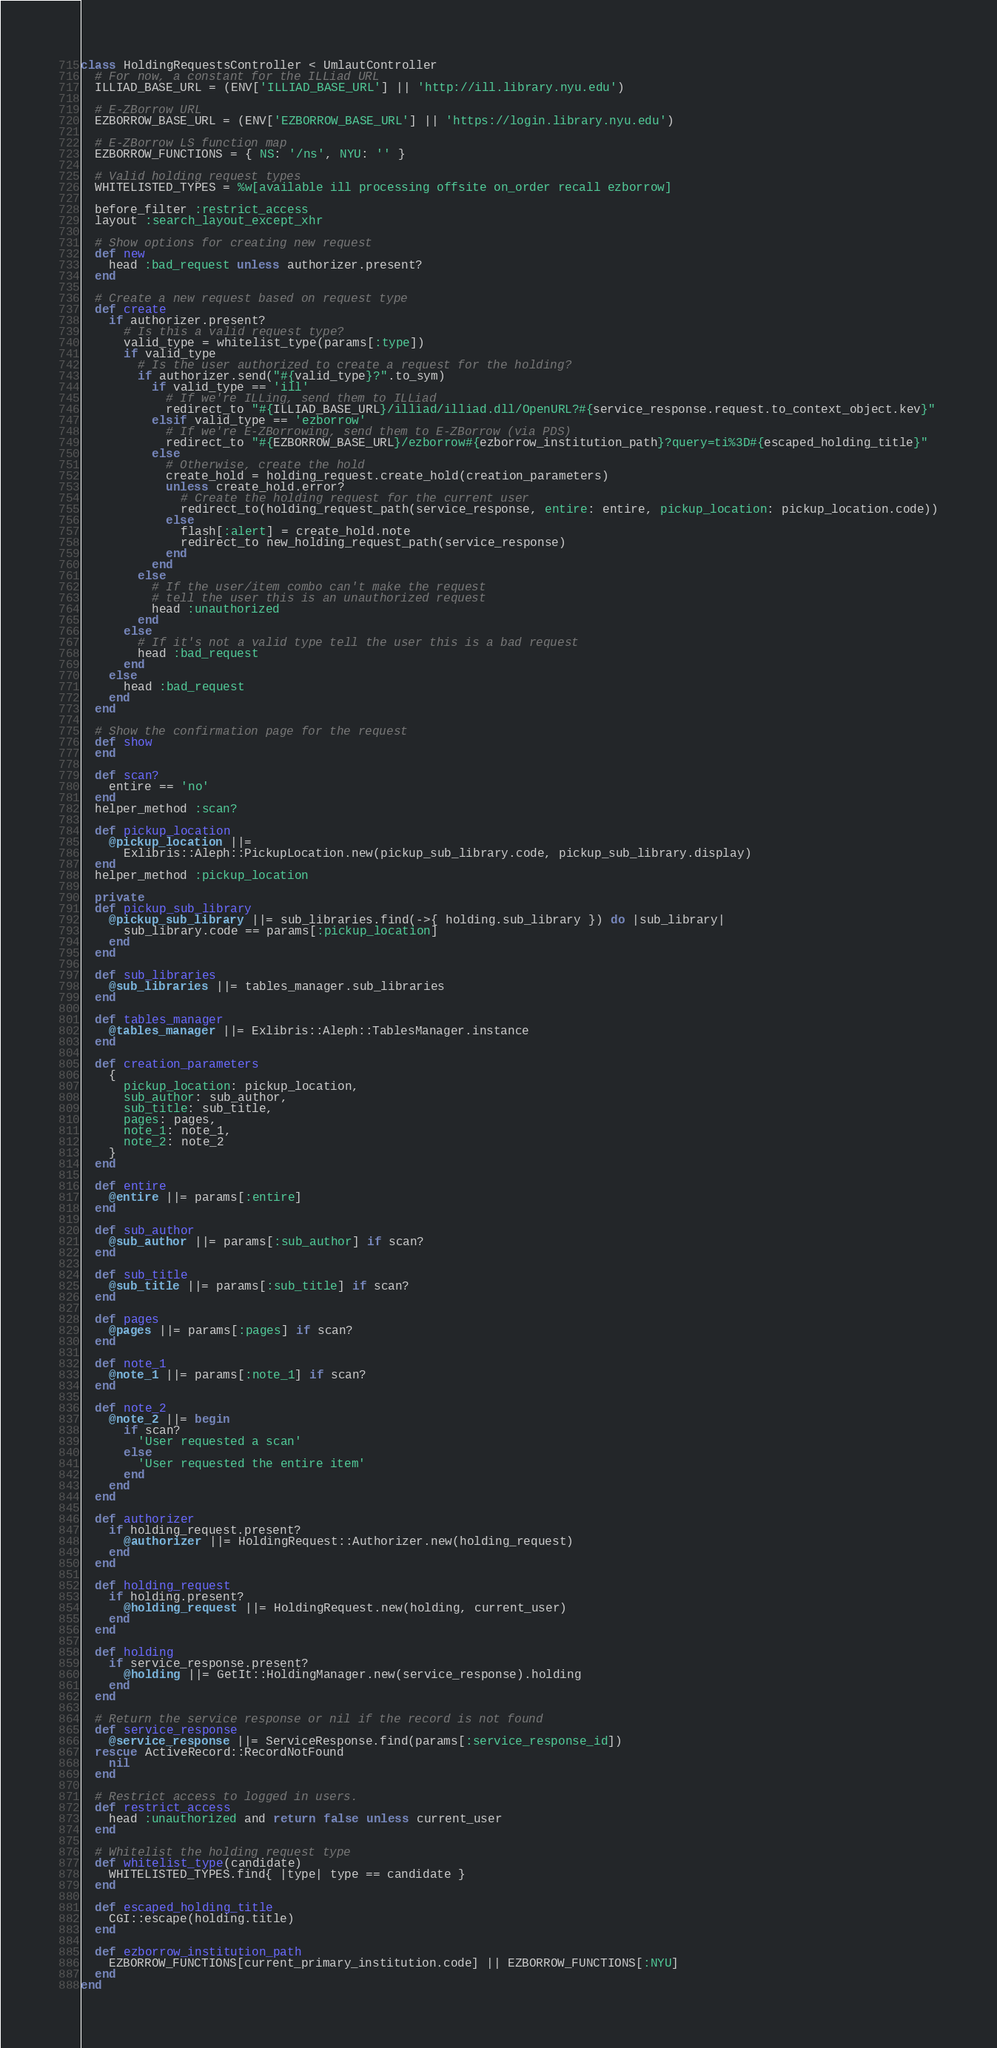<code> <loc_0><loc_0><loc_500><loc_500><_Ruby_>class HoldingRequestsController < UmlautController
  # For now, a constant for the ILLiad URL
  ILLIAD_BASE_URL = (ENV['ILLIAD_BASE_URL'] || 'http://ill.library.nyu.edu')

  # E-ZBorrow URL
  EZBORROW_BASE_URL = (ENV['EZBORROW_BASE_URL'] || 'https://login.library.nyu.edu')

  # E-ZBorrow LS function map
  EZBORROW_FUNCTIONS = { NS: '/ns', NYU: '' }

  # Valid holding request types
  WHITELISTED_TYPES = %w[available ill processing offsite on_order recall ezborrow]

  before_filter :restrict_access
  layout :search_layout_except_xhr

  # Show options for creating new request
  def new
    head :bad_request unless authorizer.present?
  end

  # Create a new request based on request type
  def create
    if authorizer.present?
      # Is this a valid request type?
      valid_type = whitelist_type(params[:type])
      if valid_type
        # Is the user authorized to create a request for the holding?
        if authorizer.send("#{valid_type}?".to_sym)
          if valid_type == 'ill'
            # If we're ILLing, send them to ILLiad
            redirect_to "#{ILLIAD_BASE_URL}/illiad/illiad.dll/OpenURL?#{service_response.request.to_context_object.kev}"
          elsif valid_type == 'ezborrow'
            # If we're E-ZBorrowing, send them to E-ZBorrow (via PDS)
            redirect_to "#{EZBORROW_BASE_URL}/ezborrow#{ezborrow_institution_path}?query=ti%3D#{escaped_holding_title}"
          else
            # Otherwise, create the hold
            create_hold = holding_request.create_hold(creation_parameters)
            unless create_hold.error?
              # Create the holding request for the current user
              redirect_to(holding_request_path(service_response, entire: entire, pickup_location: pickup_location.code))
            else
              flash[:alert] = create_hold.note
              redirect_to new_holding_request_path(service_response)
            end
          end
        else
          # If the user/item combo can't make the request
          # tell the user this is an unauthorized request
          head :unauthorized
        end
      else
        # If it's not a valid type tell the user this is a bad request
        head :bad_request
      end
    else
      head :bad_request
    end
  end

  # Show the confirmation page for the request
  def show
  end

  def scan?
    entire == 'no'
  end
  helper_method :scan?

  def pickup_location
    @pickup_location ||=
      Exlibris::Aleph::PickupLocation.new(pickup_sub_library.code, pickup_sub_library.display)
  end
  helper_method :pickup_location

  private
  def pickup_sub_library
    @pickup_sub_library ||= sub_libraries.find(->{ holding.sub_library }) do |sub_library|
      sub_library.code == params[:pickup_location]
    end
  end

  def sub_libraries
    @sub_libraries ||= tables_manager.sub_libraries
  end

  def tables_manager
    @tables_manager ||= Exlibris::Aleph::TablesManager.instance
  end

  def creation_parameters
    {
      pickup_location: pickup_location,
      sub_author: sub_author,
      sub_title: sub_title,
      pages: pages,
      note_1: note_1,
      note_2: note_2
    }
  end

  def entire
    @entire ||= params[:entire]
  end

  def sub_author
    @sub_author ||= params[:sub_author] if scan?
  end

  def sub_title
    @sub_title ||= params[:sub_title] if scan?
  end

  def pages
    @pages ||= params[:pages] if scan?
  end

  def note_1
    @note_1 ||= params[:note_1] if scan?
  end

  def note_2
    @note_2 ||= begin
      if scan?
        'User requested a scan'
      else
        'User requested the entire item'
      end
    end
  end

  def authorizer
    if holding_request.present?
      @authorizer ||= HoldingRequest::Authorizer.new(holding_request)
    end
  end

  def holding_request
    if holding.present?
      @holding_request ||= HoldingRequest.new(holding, current_user)
    end
  end

  def holding
    if service_response.present?
      @holding ||= GetIt::HoldingManager.new(service_response).holding
    end
  end

  # Return the service response or nil if the record is not found
  def service_response
    @service_response ||= ServiceResponse.find(params[:service_response_id])
  rescue ActiveRecord::RecordNotFound
    nil
  end

  # Restrict access to logged in users.
  def restrict_access
    head :unauthorized and return false unless current_user
  end

  # Whitelist the holding request type
  def whitelist_type(candidate)
    WHITELISTED_TYPES.find{ |type| type == candidate }
  end

  def escaped_holding_title
    CGI::escape(holding.title)
  end

  def ezborrow_institution_path
    EZBORROW_FUNCTIONS[current_primary_institution.code] || EZBORROW_FUNCTIONS[:NYU]
  end
end
</code> 